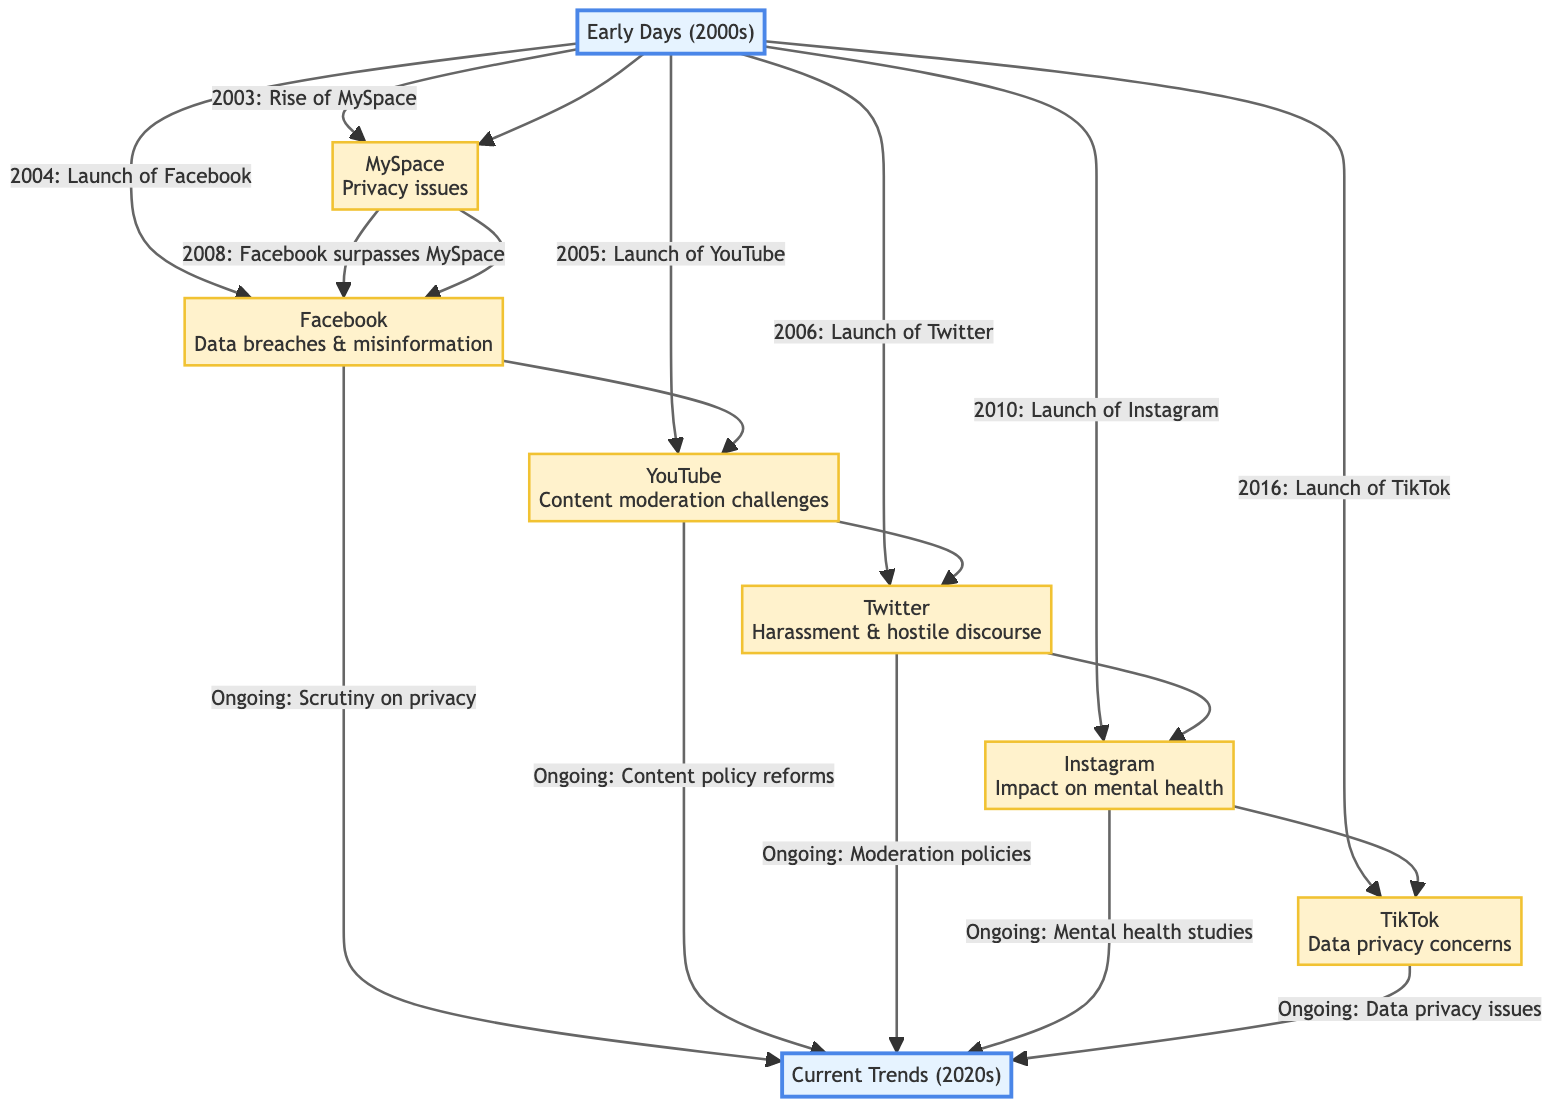What year did MySpace rise? According to the flowchart, MySpace rose in 2003, as indicated by the connection from the "Early Days (2000s)" node to the "MySpace" node.
Answer: 2003 How many platforms are listed in the diagram? The diagram contains six platforms: MySpace, Facebook, YouTube, Twitter, Instagram, and TikTok. Therefore, counting these nodes gives a total of six platforms.
Answer: 6 What controversy is associated with Facebook? The diagram explicitly states "Data breaches & misinformation" as the controversy linked to Facebook. This is indicated directly under the Facebook node.
Answer: Data breaches & misinformation Which social media platform launched in 2010? By examining the launches listed, the "Instagram" node specifies 2010 as its launch year, confirming it as the platform launched that year.
Answer: Instagram What is the ongoing issue for TikTok? The diagram shows that "Data privacy issues" is an ongoing concern related to TikTok, as mentioned in the link from the TikTok node to the "Current Trends (2020s)" node.
Answer: Data privacy issues What major event occurred in 2008 according to the diagram? The diagram indicates that in 2008, "Facebook surpasses MySpace," which is a significant event mentioned in the flow between the MySpace and Facebook nodes.
Answer: Facebook surpasses MySpace Identify the earliest social media platform mentioned. The flowchart indicates that MySpace is the earliest platform noted, as it is the first platform listed under the "Early Days (2000s)" era.
Answer: MySpace Which controversy involves YouTube? The controversy linked to YouTube is stated as "Content moderation challenges," appearing directly beneath the YouTube node in the diagram.
Answer: Content moderation challenges How are current controversies categorized in the diagram? Current controversies are documented as "Ongoing" issues for each platform, leading to the "Current Trends (2020s)" node from each respective platform node. This indicates a shared category for contemporary concerns across multiple platforms.
Answer: Ongoing What is the relationship between Twitter and harassment? The diagram shows a direct connection between the Twitter node and the controversy labeled "Harassment & hostile discourse," indicating a linked relationship between the platform and this specific issue.
Answer: Harassment & hostile discourse 